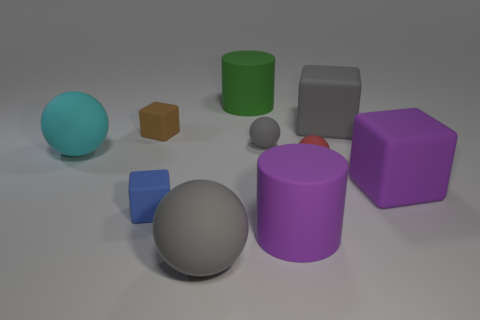Subtract all big cyan balls. How many balls are left? 3 Subtract 2 blocks. How many blocks are left? 2 Subtract all purple blocks. How many blocks are left? 3 Add 2 tiny blue objects. How many tiny blue objects exist? 3 Subtract 0 purple spheres. How many objects are left? 10 Subtract all cylinders. How many objects are left? 8 Subtract all red spheres. Subtract all blue cubes. How many spheres are left? 3 Subtract all green blocks. How many yellow spheres are left? 0 Subtract all brown matte cubes. Subtract all cyan things. How many objects are left? 8 Add 9 small red matte spheres. How many small red matte spheres are left? 10 